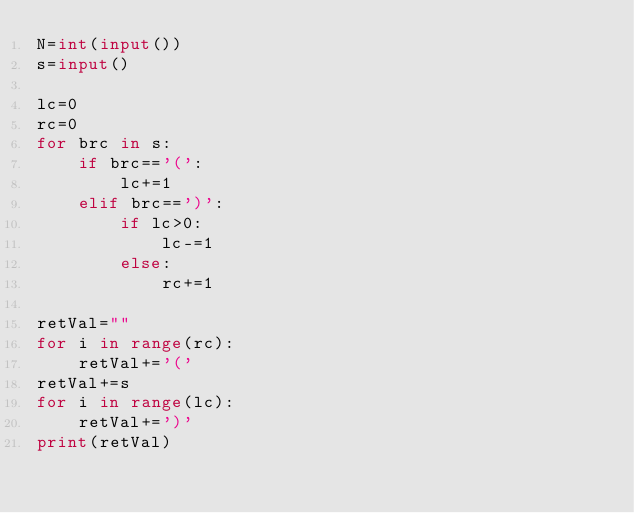Convert code to text. <code><loc_0><loc_0><loc_500><loc_500><_Python_>N=int(input())
s=input()

lc=0
rc=0
for brc in s:
    if brc=='(':
        lc+=1
    elif brc==')':
        if lc>0:
            lc-=1
        else:
            rc+=1
            
retVal=""
for i in range(rc):
    retVal+='('
retVal+=s
for i in range(lc):
    retVal+=')'
print(retVal)</code> 